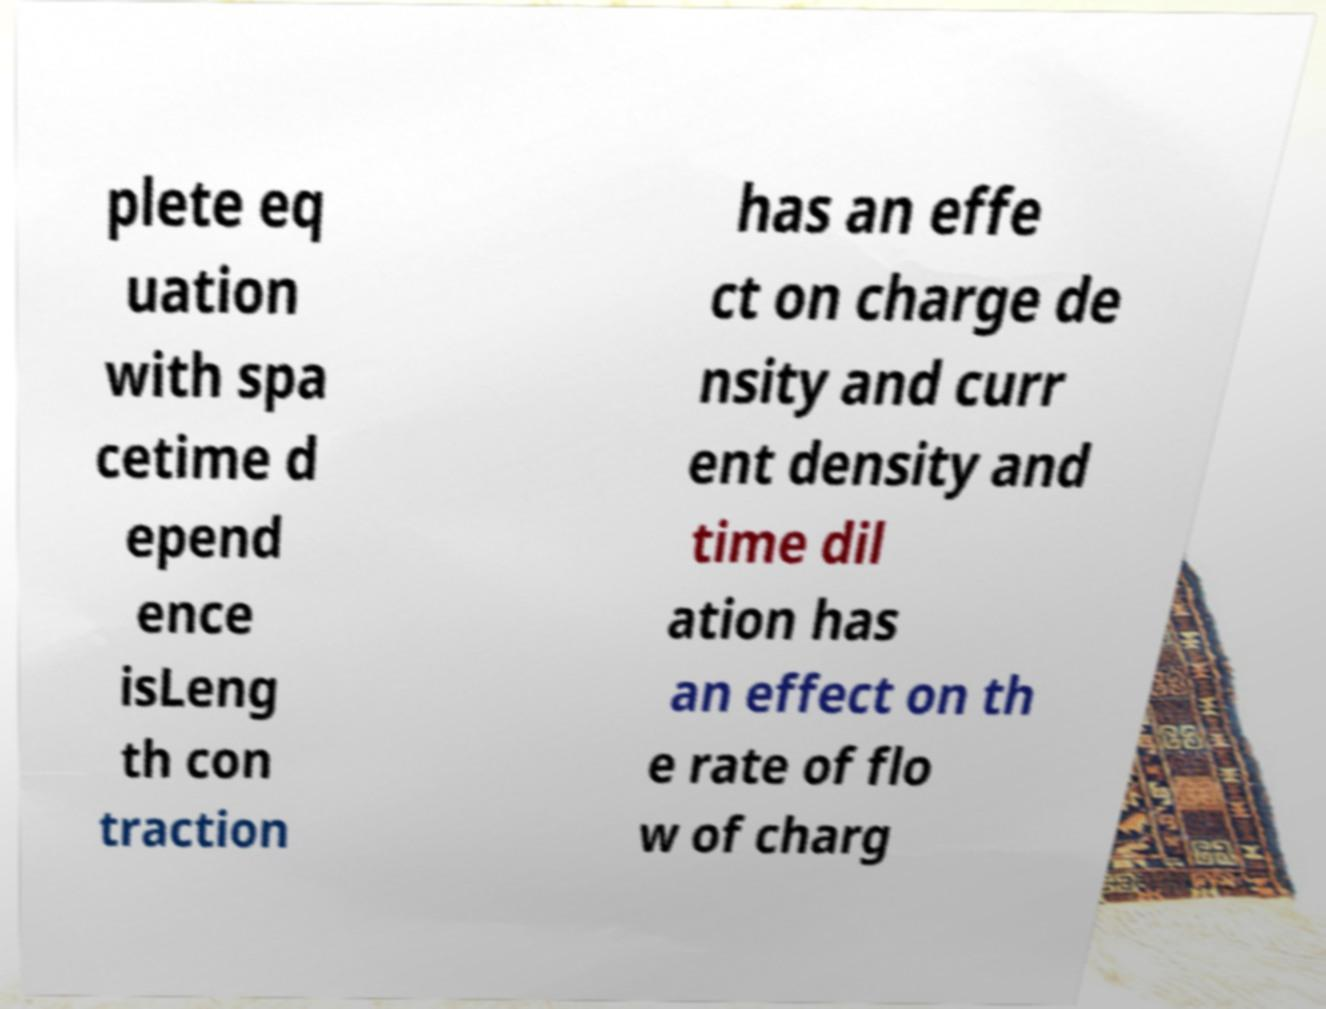For documentation purposes, I need the text within this image transcribed. Could you provide that? plete eq uation with spa cetime d epend ence isLeng th con traction has an effe ct on charge de nsity and curr ent density and time dil ation has an effect on th e rate of flo w of charg 